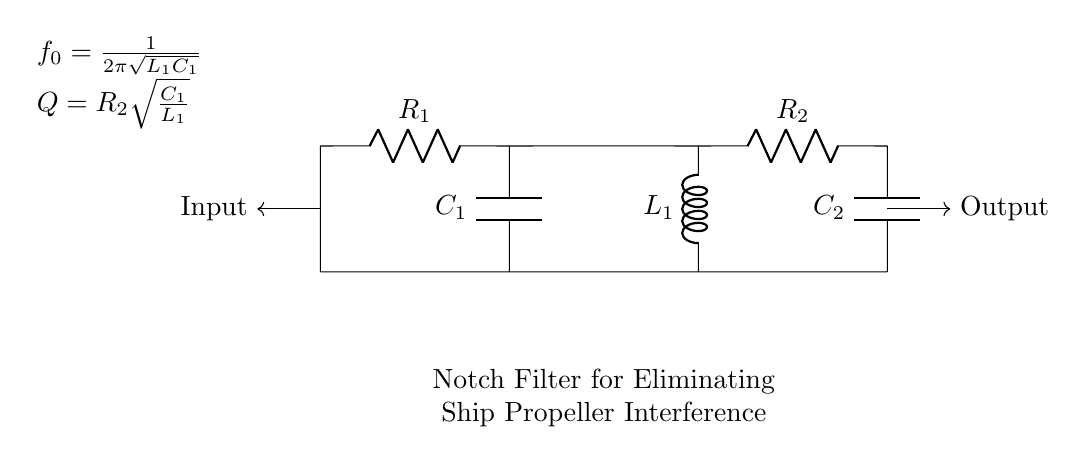What is the purpose of this circuit? The circuit is designed to eliminate interference from ship propellers in underwater acoustic measurements through a notch filter.
Answer: Eliminating interference What components are present in the circuit? The circuit contains resistors, capacitors, and an inductor, specifically labeled R1, R2, C1, C2, and L1.
Answer: Resistors, capacitors, inductor What is the resonant frequency formula? The resonant frequency is given by the formula f0 = 1/(2π√(L1C1)), which shows how inductance and capacitance are related to the frequency.
Answer: f0 = 1/(2π√(L1C1)) How does increasing R2 affect the circuit? Increasing R2 will increase the quality factor Q of the filter, affecting its bandwidth and selectivity, leading to a sharper notch.
Answer: Increases quality factor What is the role of L1 in this filter? L1 acts as an inductor in the circuit, contributing to the filter's design to isolate specific frequency interference while allowing others to pass.
Answer: Isolation of frequency What is the quality factor equation? The quality factor Q is represented by the formula Q = R2√(C1/L1), indicating the relationship between resistance, capacitance, and inductance.
Answer: Q = R2√(C1/L1) What happens if C1 is increased? Increasing C1 lowers the resonant frequency f0, potentially widening the notch, thereby allowing more frequencies to pass through.
Answer: Lowers resonant frequency 